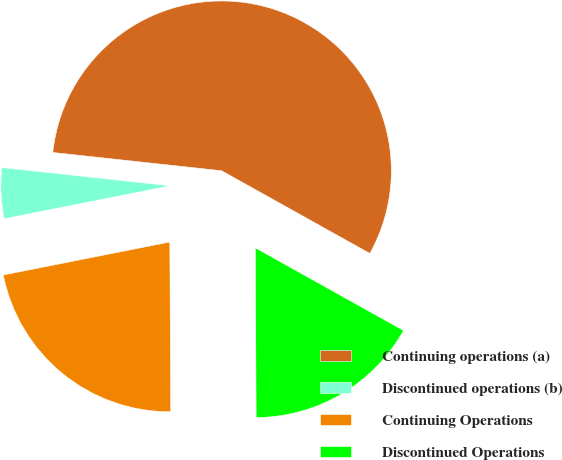Convert chart. <chart><loc_0><loc_0><loc_500><loc_500><pie_chart><fcel>Continuing operations (a)<fcel>Discontinued operations (b)<fcel>Continuing Operations<fcel>Discontinued Operations<nl><fcel>56.38%<fcel>4.83%<fcel>21.97%<fcel>16.82%<nl></chart> 